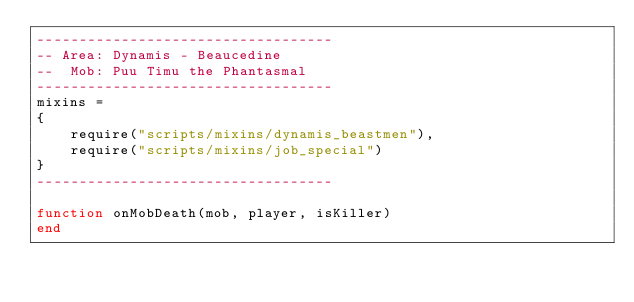Convert code to text. <code><loc_0><loc_0><loc_500><loc_500><_Lua_>-----------------------------------
-- Area: Dynamis - Beaucedine
--  Mob: Puu Timu the Phantasmal
-----------------------------------
mixins =
{
    require("scripts/mixins/dynamis_beastmen"),
    require("scripts/mixins/job_special")
}
-----------------------------------

function onMobDeath(mob, player, isKiller)
end
</code> 